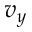Convert formula to latex. <formula><loc_0><loc_0><loc_500><loc_500>v _ { y }</formula> 